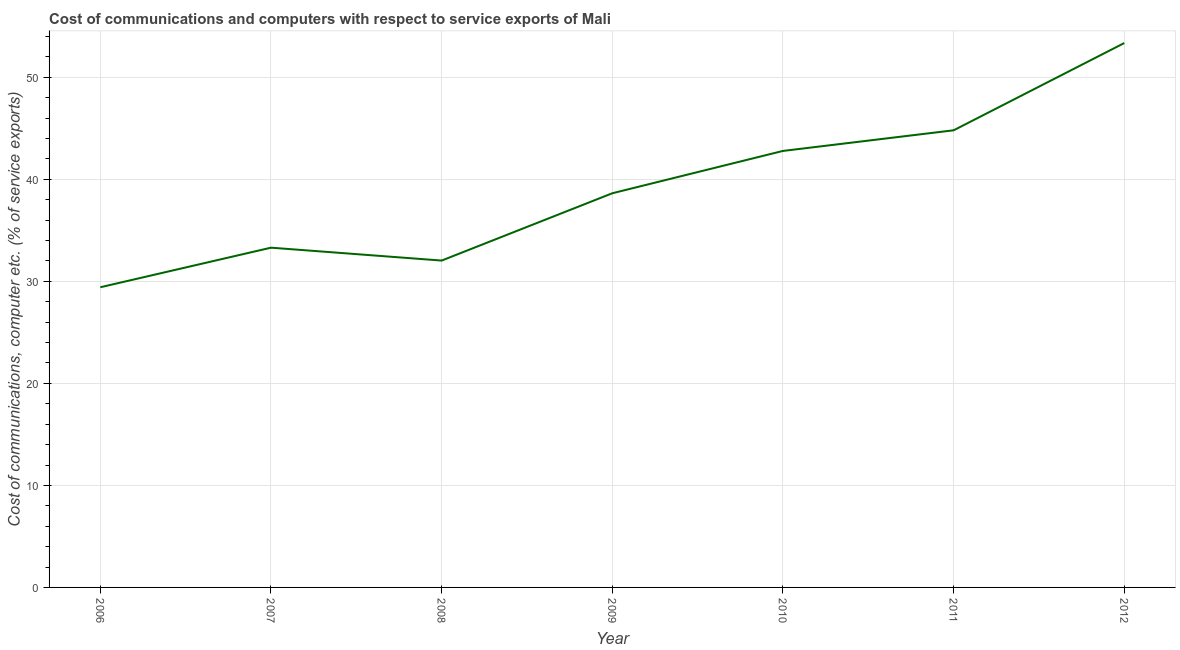What is the cost of communications and computer in 2010?
Your answer should be very brief. 42.79. Across all years, what is the maximum cost of communications and computer?
Provide a short and direct response. 53.36. Across all years, what is the minimum cost of communications and computer?
Your answer should be very brief. 29.42. What is the sum of the cost of communications and computer?
Offer a very short reply. 274.35. What is the difference between the cost of communications and computer in 2007 and 2010?
Your answer should be compact. -9.48. What is the average cost of communications and computer per year?
Keep it short and to the point. 39.19. What is the median cost of communications and computer?
Give a very brief answer. 38.64. In how many years, is the cost of communications and computer greater than 28 %?
Ensure brevity in your answer.  7. What is the ratio of the cost of communications and computer in 2011 to that in 2012?
Provide a short and direct response. 0.84. Is the difference between the cost of communications and computer in 2006 and 2009 greater than the difference between any two years?
Provide a short and direct response. No. What is the difference between the highest and the second highest cost of communications and computer?
Your answer should be compact. 8.55. What is the difference between the highest and the lowest cost of communications and computer?
Make the answer very short. 23.94. Does the graph contain grids?
Offer a very short reply. Yes. What is the title of the graph?
Your answer should be compact. Cost of communications and computers with respect to service exports of Mali. What is the label or title of the X-axis?
Provide a succinct answer. Year. What is the label or title of the Y-axis?
Offer a very short reply. Cost of communications, computer etc. (% of service exports). What is the Cost of communications, computer etc. (% of service exports) in 2006?
Your response must be concise. 29.42. What is the Cost of communications, computer etc. (% of service exports) in 2007?
Give a very brief answer. 33.3. What is the Cost of communications, computer etc. (% of service exports) of 2008?
Offer a very short reply. 32.04. What is the Cost of communications, computer etc. (% of service exports) of 2009?
Offer a terse response. 38.64. What is the Cost of communications, computer etc. (% of service exports) of 2010?
Your answer should be compact. 42.79. What is the Cost of communications, computer etc. (% of service exports) of 2011?
Your response must be concise. 44.81. What is the Cost of communications, computer etc. (% of service exports) in 2012?
Provide a short and direct response. 53.36. What is the difference between the Cost of communications, computer etc. (% of service exports) in 2006 and 2007?
Give a very brief answer. -3.88. What is the difference between the Cost of communications, computer etc. (% of service exports) in 2006 and 2008?
Offer a very short reply. -2.61. What is the difference between the Cost of communications, computer etc. (% of service exports) in 2006 and 2009?
Your answer should be compact. -9.21. What is the difference between the Cost of communications, computer etc. (% of service exports) in 2006 and 2010?
Your response must be concise. -13.36. What is the difference between the Cost of communications, computer etc. (% of service exports) in 2006 and 2011?
Make the answer very short. -15.38. What is the difference between the Cost of communications, computer etc. (% of service exports) in 2006 and 2012?
Offer a terse response. -23.94. What is the difference between the Cost of communications, computer etc. (% of service exports) in 2007 and 2008?
Your answer should be very brief. 1.26. What is the difference between the Cost of communications, computer etc. (% of service exports) in 2007 and 2009?
Ensure brevity in your answer.  -5.33. What is the difference between the Cost of communications, computer etc. (% of service exports) in 2007 and 2010?
Give a very brief answer. -9.48. What is the difference between the Cost of communications, computer etc. (% of service exports) in 2007 and 2011?
Offer a terse response. -11.51. What is the difference between the Cost of communications, computer etc. (% of service exports) in 2007 and 2012?
Ensure brevity in your answer.  -20.06. What is the difference between the Cost of communications, computer etc. (% of service exports) in 2008 and 2009?
Your answer should be very brief. -6.6. What is the difference between the Cost of communications, computer etc. (% of service exports) in 2008 and 2010?
Provide a short and direct response. -10.75. What is the difference between the Cost of communications, computer etc. (% of service exports) in 2008 and 2011?
Your answer should be compact. -12.77. What is the difference between the Cost of communications, computer etc. (% of service exports) in 2008 and 2012?
Make the answer very short. -21.32. What is the difference between the Cost of communications, computer etc. (% of service exports) in 2009 and 2010?
Provide a succinct answer. -4.15. What is the difference between the Cost of communications, computer etc. (% of service exports) in 2009 and 2011?
Make the answer very short. -6.17. What is the difference between the Cost of communications, computer etc. (% of service exports) in 2009 and 2012?
Give a very brief answer. -14.72. What is the difference between the Cost of communications, computer etc. (% of service exports) in 2010 and 2011?
Keep it short and to the point. -2.02. What is the difference between the Cost of communications, computer etc. (% of service exports) in 2010 and 2012?
Your answer should be compact. -10.58. What is the difference between the Cost of communications, computer etc. (% of service exports) in 2011 and 2012?
Your response must be concise. -8.55. What is the ratio of the Cost of communications, computer etc. (% of service exports) in 2006 to that in 2007?
Provide a succinct answer. 0.88. What is the ratio of the Cost of communications, computer etc. (% of service exports) in 2006 to that in 2008?
Provide a short and direct response. 0.92. What is the ratio of the Cost of communications, computer etc. (% of service exports) in 2006 to that in 2009?
Provide a short and direct response. 0.76. What is the ratio of the Cost of communications, computer etc. (% of service exports) in 2006 to that in 2010?
Your answer should be very brief. 0.69. What is the ratio of the Cost of communications, computer etc. (% of service exports) in 2006 to that in 2011?
Provide a succinct answer. 0.66. What is the ratio of the Cost of communications, computer etc. (% of service exports) in 2006 to that in 2012?
Offer a very short reply. 0.55. What is the ratio of the Cost of communications, computer etc. (% of service exports) in 2007 to that in 2008?
Provide a succinct answer. 1.04. What is the ratio of the Cost of communications, computer etc. (% of service exports) in 2007 to that in 2009?
Your answer should be very brief. 0.86. What is the ratio of the Cost of communications, computer etc. (% of service exports) in 2007 to that in 2010?
Give a very brief answer. 0.78. What is the ratio of the Cost of communications, computer etc. (% of service exports) in 2007 to that in 2011?
Provide a short and direct response. 0.74. What is the ratio of the Cost of communications, computer etc. (% of service exports) in 2007 to that in 2012?
Provide a short and direct response. 0.62. What is the ratio of the Cost of communications, computer etc. (% of service exports) in 2008 to that in 2009?
Ensure brevity in your answer.  0.83. What is the ratio of the Cost of communications, computer etc. (% of service exports) in 2008 to that in 2010?
Your answer should be compact. 0.75. What is the ratio of the Cost of communications, computer etc. (% of service exports) in 2008 to that in 2011?
Your answer should be very brief. 0.71. What is the ratio of the Cost of communications, computer etc. (% of service exports) in 2008 to that in 2012?
Provide a succinct answer. 0.6. What is the ratio of the Cost of communications, computer etc. (% of service exports) in 2009 to that in 2010?
Your answer should be very brief. 0.9. What is the ratio of the Cost of communications, computer etc. (% of service exports) in 2009 to that in 2011?
Provide a short and direct response. 0.86. What is the ratio of the Cost of communications, computer etc. (% of service exports) in 2009 to that in 2012?
Provide a succinct answer. 0.72. What is the ratio of the Cost of communications, computer etc. (% of service exports) in 2010 to that in 2011?
Offer a terse response. 0.95. What is the ratio of the Cost of communications, computer etc. (% of service exports) in 2010 to that in 2012?
Offer a terse response. 0.8. What is the ratio of the Cost of communications, computer etc. (% of service exports) in 2011 to that in 2012?
Provide a short and direct response. 0.84. 